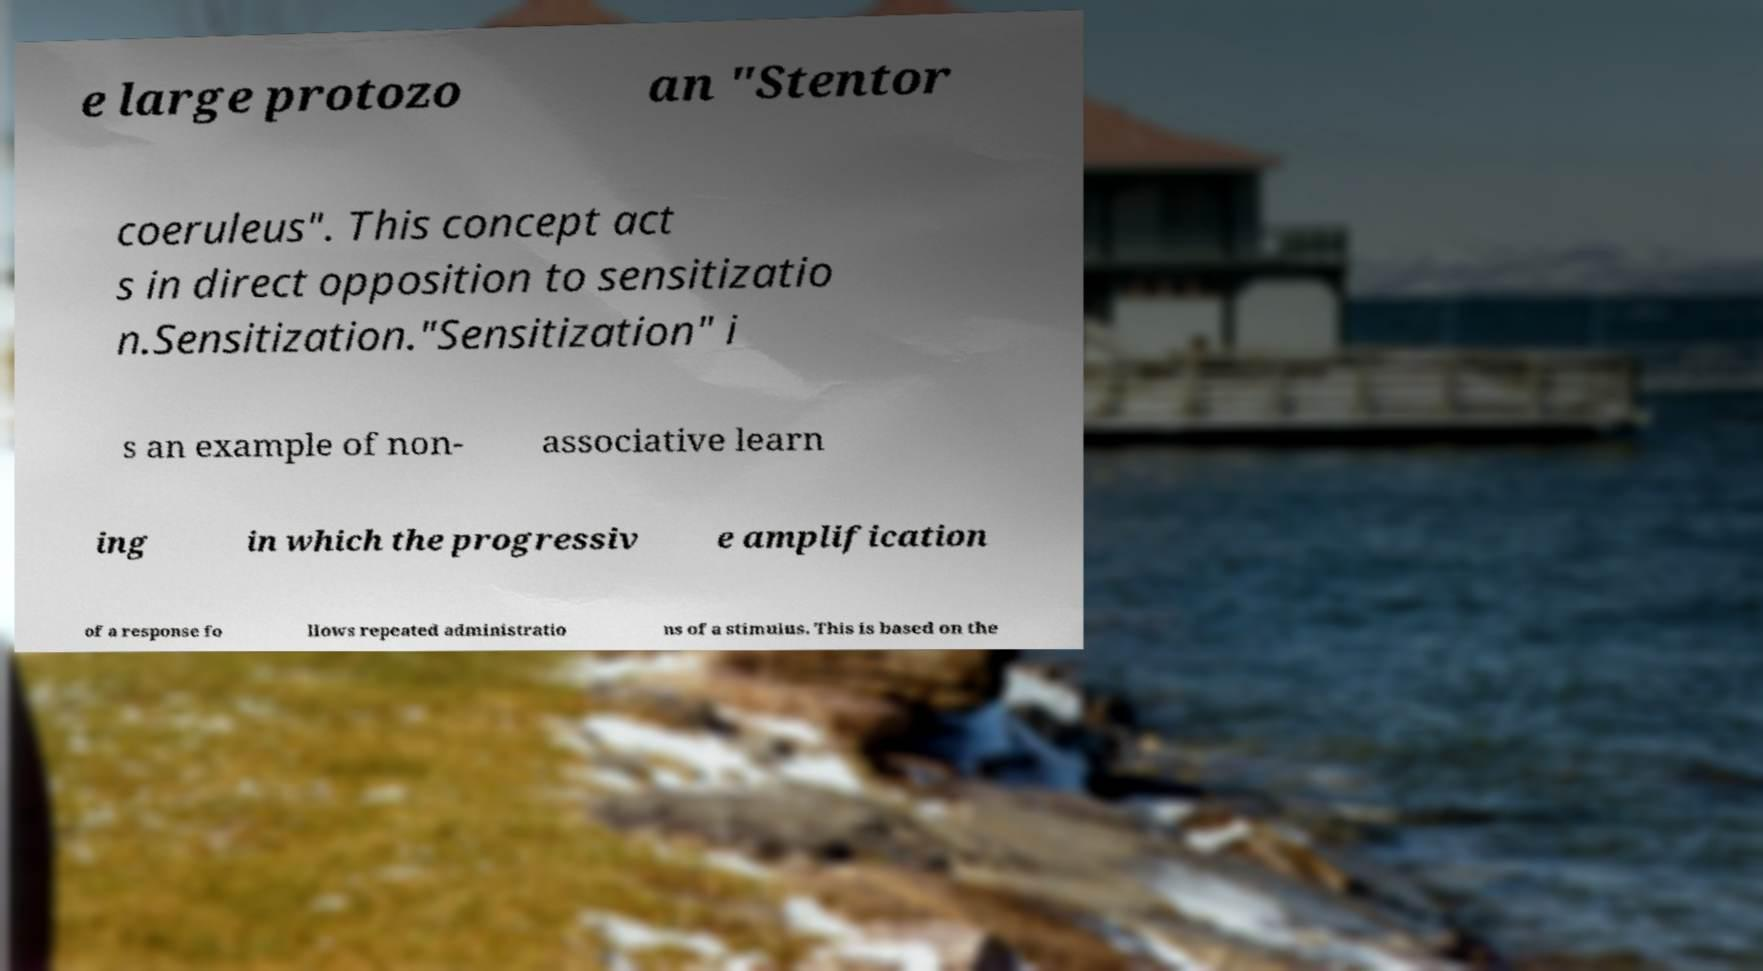Please identify and transcribe the text found in this image. e large protozo an "Stentor coeruleus". This concept act s in direct opposition to sensitizatio n.Sensitization."Sensitization" i s an example of non- associative learn ing in which the progressiv e amplification of a response fo llows repeated administratio ns of a stimulus. This is based on the 